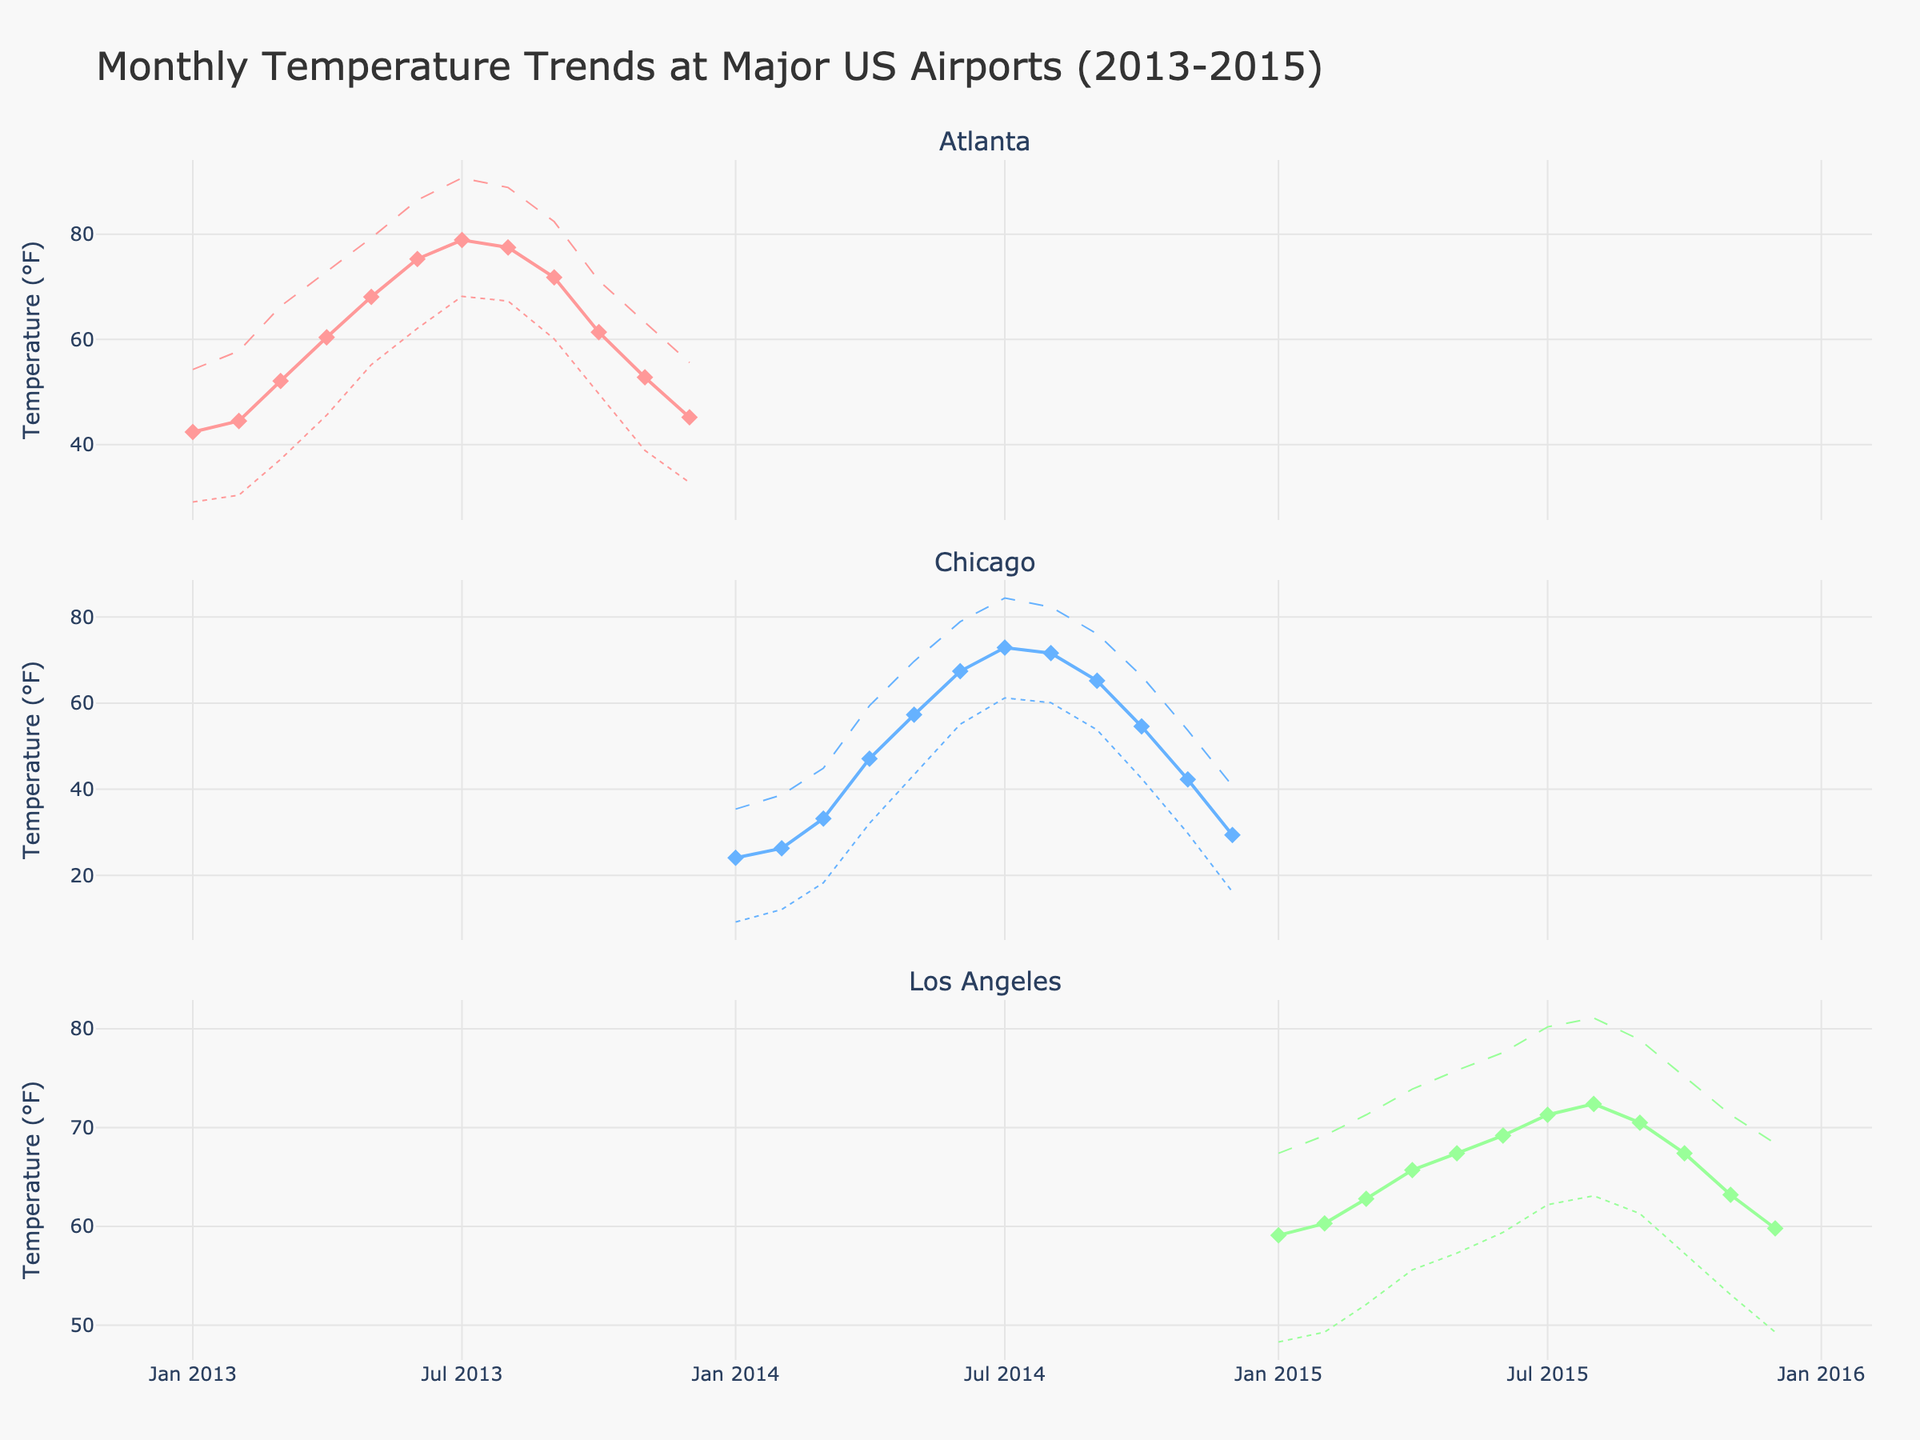What's the title of the figure? The title is located at the top of the figure. It reads "Monthly Temperature Trends at Major US Airports (2013-2015)".
Answer: Monthly Temperature Trends at Major US Airports (2013-2015) How many airports are compared in the figure? The figure contains three subplot titles corresponding to the three airports being compared: "Atlanta", "Chicago", and "Los Angeles".
Answer: 3 How does the Average Temperature for Hartsfield-Jackson Atlanta International Airport change from January to December 2013? Look at the first subplot labeled 'Atlanta', track the line representing 'Average Temp' from January to December 2013. The line starts around 42.4°F in January, rises to a peak in July at 78.9°F, and then falls to 45.2°F in December.
Answer: It rises, peaks in July, then falls What is the maximum temperature recorded at Chicago O'Hare International Airport in the entire dataset? Check the highest point in the 'Max Temp' line of the subplot titled 'Chicago'. The highest point reaches 84.4°F in July 2014.
Answer: 84.4°F Which month has the highest average temperature at Los Angeles International Airport? Look at the subplot titled 'Los Angeles' and identify the highest point on the 'Average Temp' line. The highest average temperature is observed in August 2015, at 72.4°F.
Answer: August 2015 Compare the minimum temperatures recorded in December at Hartsfield-Jackson Atlanta International Airport and Chicago O'Hare International Airport. Which is lower? Check the 'Min Temp' line for December in both the 'Atlanta' and 'Chicago' subplots. The minimum temperature for Atlanta in December 2013 is 32.8°F, while for Chicago in December 2014, it is 16.2°F. 16.2°F is lower.
Answer: Chicago In which month does Los Angeles International Airport experience its highest maximum temperature? Review the 'Max Temp' line in the 'Los Angeles' subplot. The highest maximum temperature is 81.1°F, recorded in August 2015.
Answer: August 2015 What is the average temperature difference between January and July for Chicago O'Hare International Airport? Identify the average temperatures for January and July in the 'Chicago' subplot: 24.1°F in January and 72.9°F in July. Calculate the difference: 72.9 - 24.1 = 48.8°F.
Answer: 48.8°F What trend do you see in the minimum temperatures at Hartsfield-Jackson Atlanta International Airport from August to December 2013? Trace the 'Min Temp' line in the 'Atlanta' subplot from August to December 2013. The trend shows a decline: starting from 67.3°F in August, falling steadily to 32.8°F in December.
Answer: Decline 